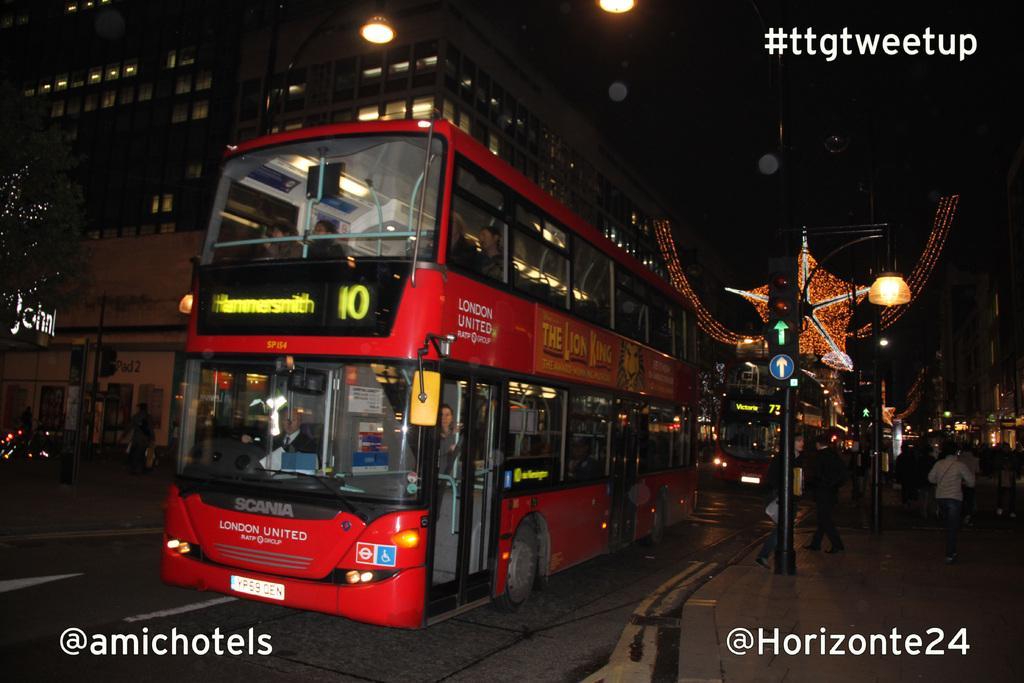In one or two sentences, can you explain what this image depicts? In the picture I can see a bus which is red in color is moving on road, there are some persons walking through the walkway and in the background of the picture there are some buildings and lights. 